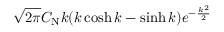<formula> <loc_0><loc_0><loc_500><loc_500>\sqrt { 2 \pi } C _ { N } k ( k \cosh k - \sinh k ) e ^ { - \frac { k ^ { 2 } } { 2 } }</formula> 